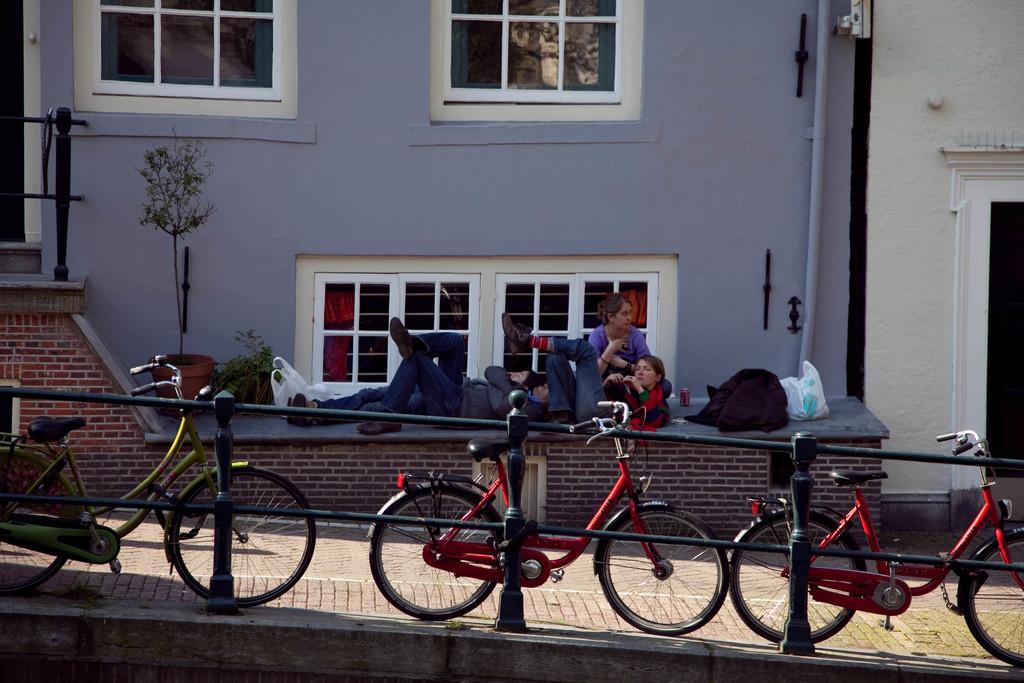How would you summarize this image in a sentence or two? In the picture I can see these cycles are parked near the fence, I can see these people are lying on the and this person is sitting here, I can see few objects are placed where, I can see flower pots, glass windows, pipes and the wall in the background. 